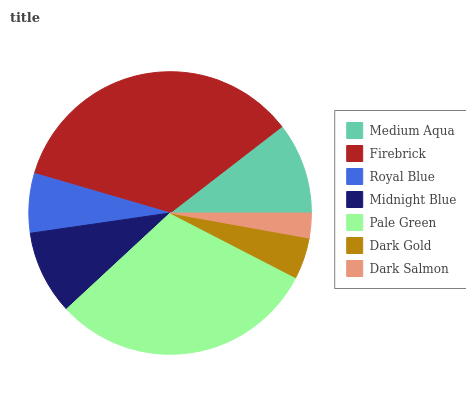Is Dark Salmon the minimum?
Answer yes or no. Yes. Is Firebrick the maximum?
Answer yes or no. Yes. Is Royal Blue the minimum?
Answer yes or no. No. Is Royal Blue the maximum?
Answer yes or no. No. Is Firebrick greater than Royal Blue?
Answer yes or no. Yes. Is Royal Blue less than Firebrick?
Answer yes or no. Yes. Is Royal Blue greater than Firebrick?
Answer yes or no. No. Is Firebrick less than Royal Blue?
Answer yes or no. No. Is Midnight Blue the high median?
Answer yes or no. Yes. Is Midnight Blue the low median?
Answer yes or no. Yes. Is Royal Blue the high median?
Answer yes or no. No. Is Dark Salmon the low median?
Answer yes or no. No. 